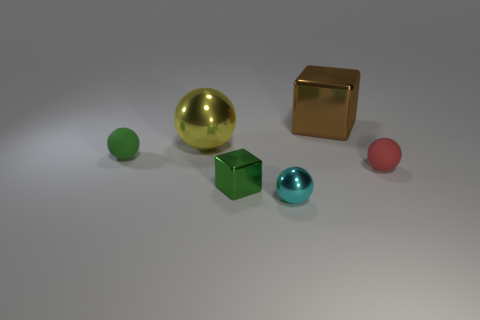Is there any other thing that has the same color as the big block?
Provide a short and direct response. No. What material is the thing that is in front of the green cube that is in front of the brown thing?
Provide a succinct answer. Metal. Are there any other yellow metal things of the same shape as the big yellow object?
Your answer should be very brief. No. What number of other objects are the same shape as the cyan object?
Give a very brief answer. 3. What is the shape of the metal thing that is behind the tiny cyan metal sphere and in front of the large yellow ball?
Your answer should be compact. Cube. There is a green thing to the right of the green matte thing; what size is it?
Make the answer very short. Small. Do the brown thing and the cyan metal object have the same size?
Give a very brief answer. No. Are there fewer small shiny objects that are behind the red matte thing than green cubes that are to the right of the brown object?
Ensure brevity in your answer.  No. There is a metallic object that is in front of the small green ball and to the right of the green metallic cube; what size is it?
Ensure brevity in your answer.  Small. Is there a green object behind the large object that is left of the metal block in front of the brown metal cube?
Your answer should be compact. No. 